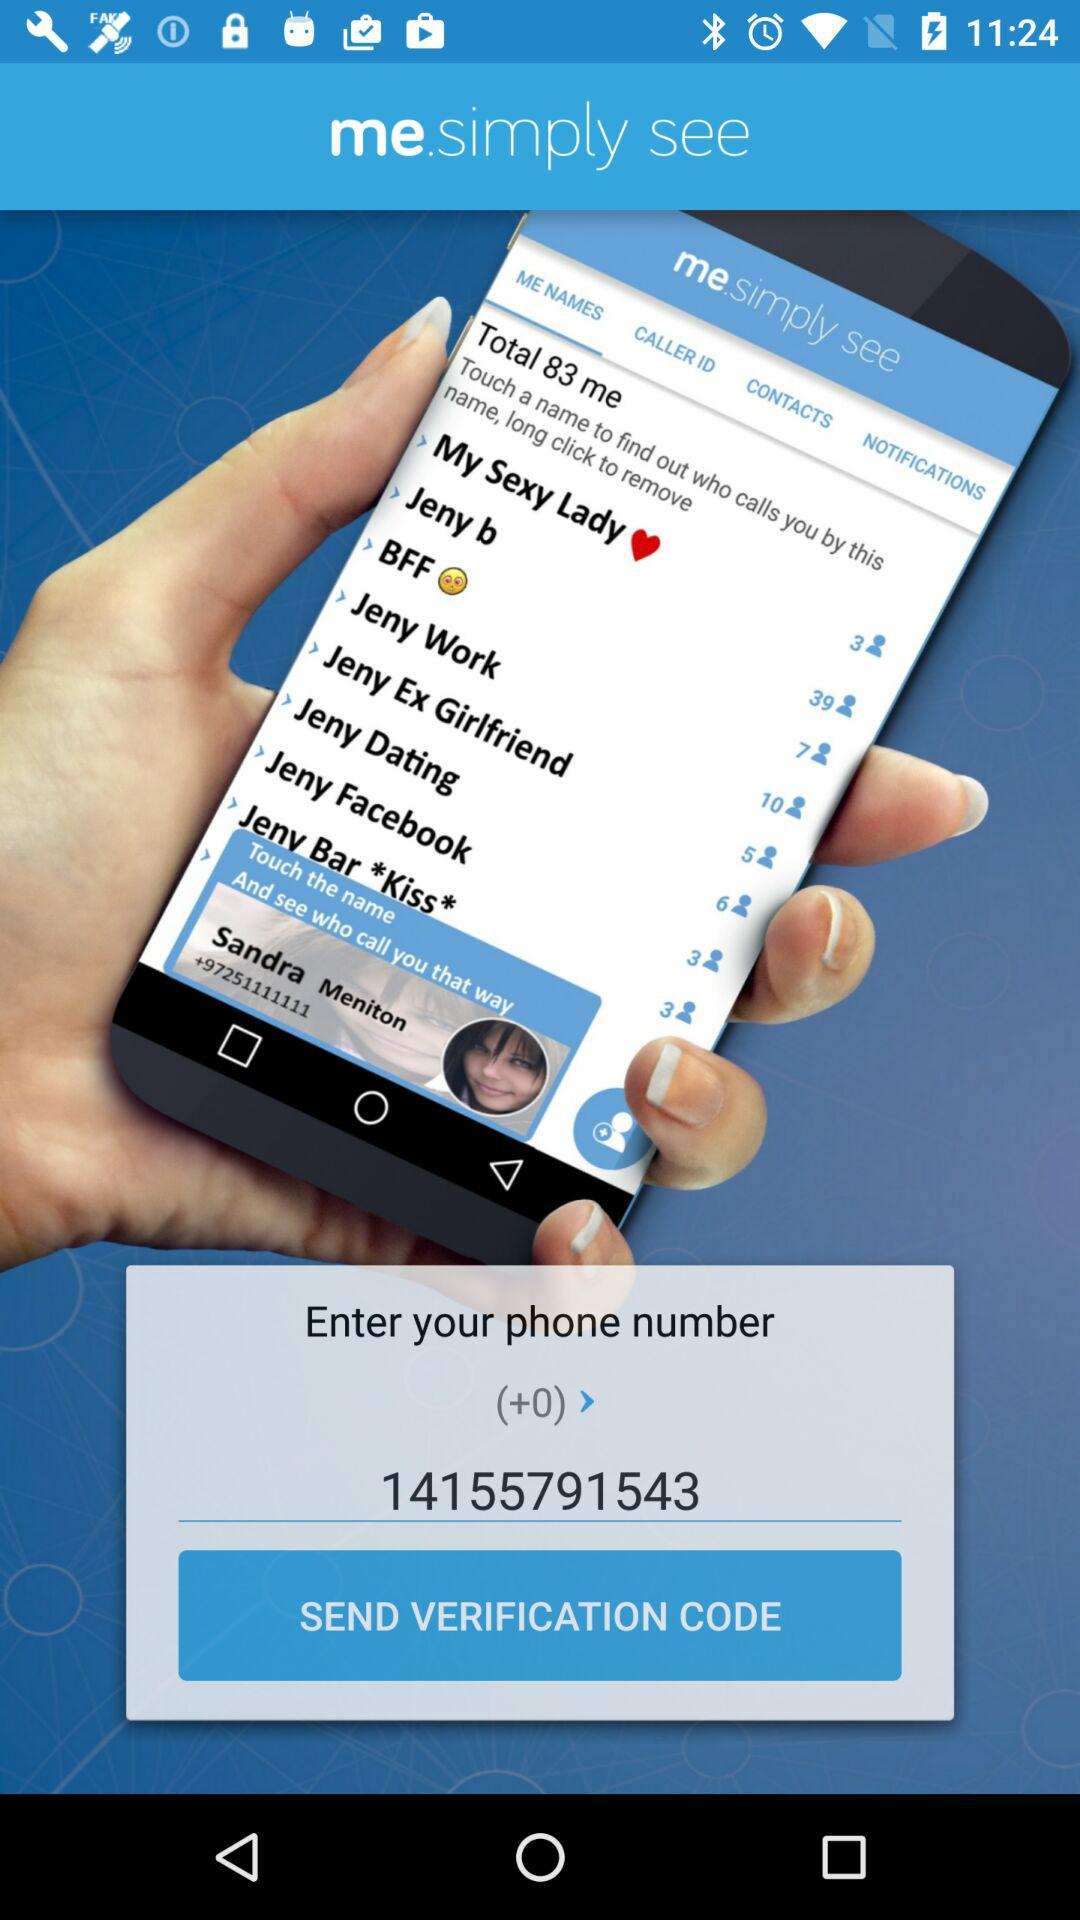What is the phone number? The phone number is +0 (14155791543). 